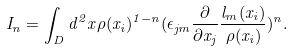Convert formula to latex. <formula><loc_0><loc_0><loc_500><loc_500>I _ { n } = \int _ { D } d ^ { 2 } x \rho ( x _ { i } ) ^ { 1 - n } ( \epsilon _ { j m } \frac { \partial } { \partial x _ { j } } \frac { l _ { m } ( x _ { i } ) } { \rho ( x _ { i } ) } ) ^ { n } .</formula> 